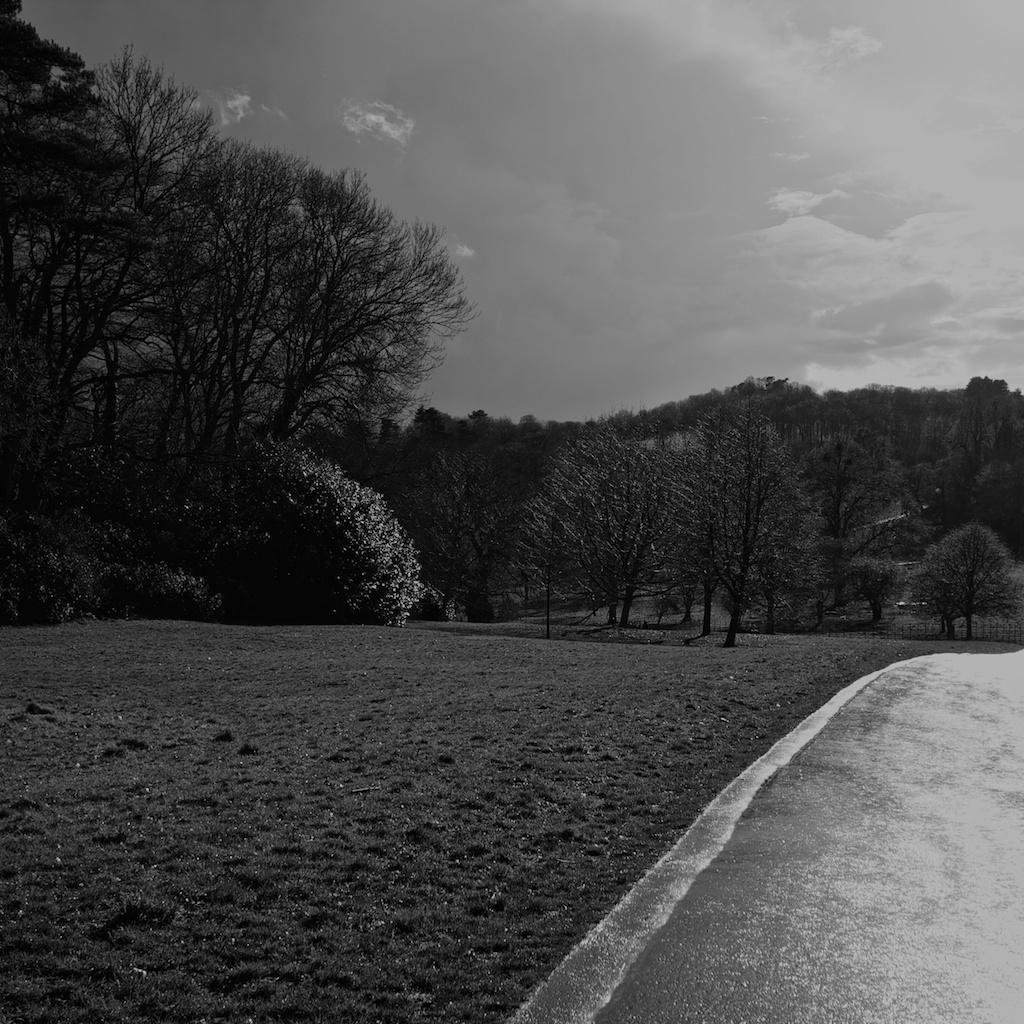What is the color scheme of the image? The image is black and white. What type of vegetation can be seen in the image? There are trees and plants in the image. What is visible on the ground in the image? The ground is visible in the image, and there is grass present. What is visible in the sky in the image? The sky is visible in the image, and there are clouds present. What type of card is being used to play a game in the image? There is no card or game present in the image; it features a black and white scene with trees, plants, grass, and clouds. What color is the tongue of the person in the image? There is no person or tongue present in the image; it is a black and white scene with natural elements. 